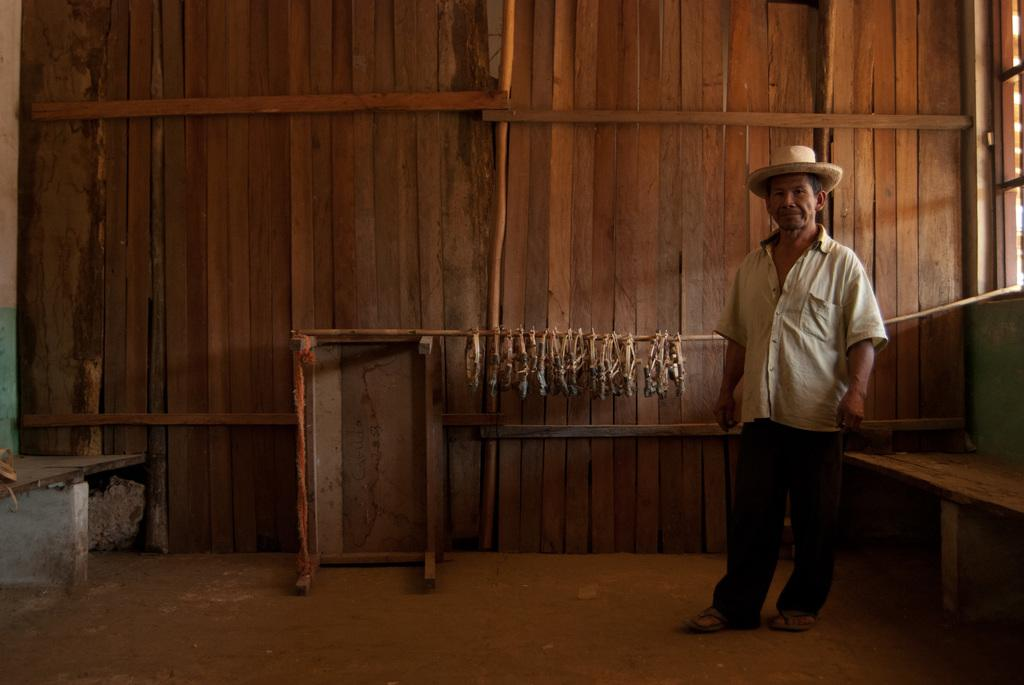What type of wall is visible in the image? There is a wooden wall in the image. Who is present in the image? There is a man in the image. What is the man wearing on his head? The man is wearing a cream-colored hat. What is the man wearing on his upper body? The man is wearing a cream-colored shirt. On which side of the image is the man standing? The man is standing on the right side of the image. How many mice are crawling on the wooden wall in the image? There are no mice present in the image; it only features a man and a wooden wall. What does the queen say about the man's attire in the image? There is no queen present in the image, so it is not possible to answer this question. 